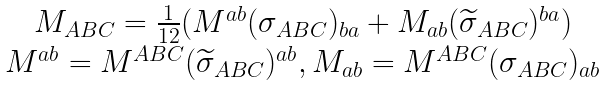Convert formula to latex. <formula><loc_0><loc_0><loc_500><loc_500>\begin{array} { c } M _ { A B C } = \frac { 1 } { 1 2 } ( M ^ { a b } ( \sigma _ { A B C } ) _ { b a } + M _ { a b } ( \widetilde { \sigma } _ { A B C } ) ^ { b a } ) \\ M ^ { a b } = M ^ { A B C } ( \widetilde { \sigma } _ { A B C } ) ^ { a b } , M _ { a b } = M ^ { A B C } ( \sigma _ { A B C } ) _ { a b } \end{array}</formula> 